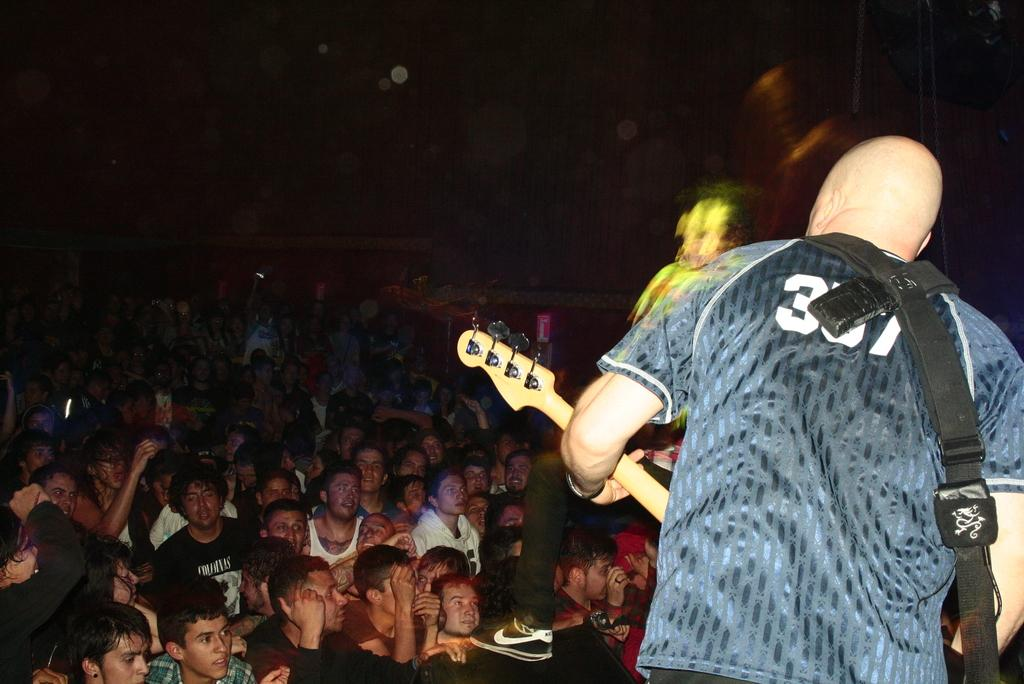What is the man in the image doing? The man in the image is playing a musical instrument. Who else is present in the image besides the man playing the musical instrument? There is a group of people in the image. What role does the group of people play in the scene? The group of people is serving as an audience for the man playing the musical instrument. What type of reaction can be seen from the spiders in the image? There are no spiders present in the image, so it is not possible to determine their reaction. 